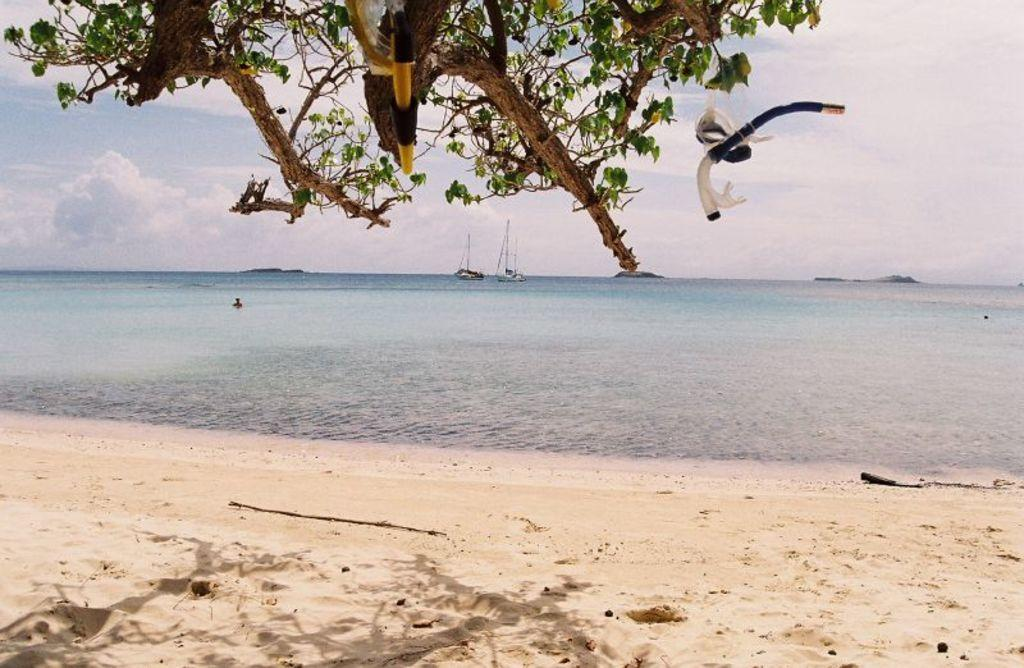What type of surface is present in the image? There is soil in the image. What can be seen in the image besides the soil? There is water, a tree, objects, and the sky visible in the image. What is the background of the image? The sky is visible in the background of the image, and there are boats present as well. Can you tell me how many snails are crawling on the tree in the image? There are no snails present on the tree in the image. What type of fruit is hanging from the tree in the image? The image does not show any fruit hanging from the tree; it only shows a tree with leaves. 